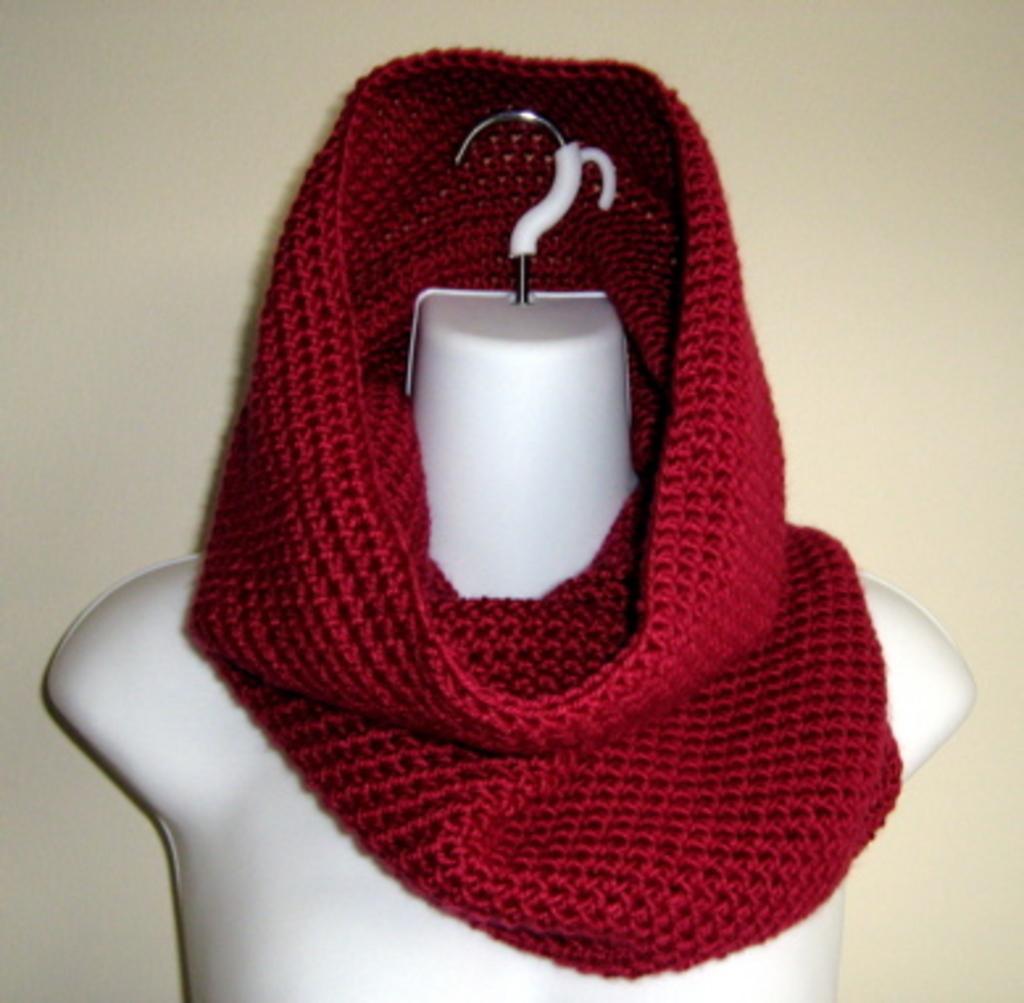Describe this image in one or two sentences. In this picture there is a red color stole on the dummy. At the back there's a wall. 